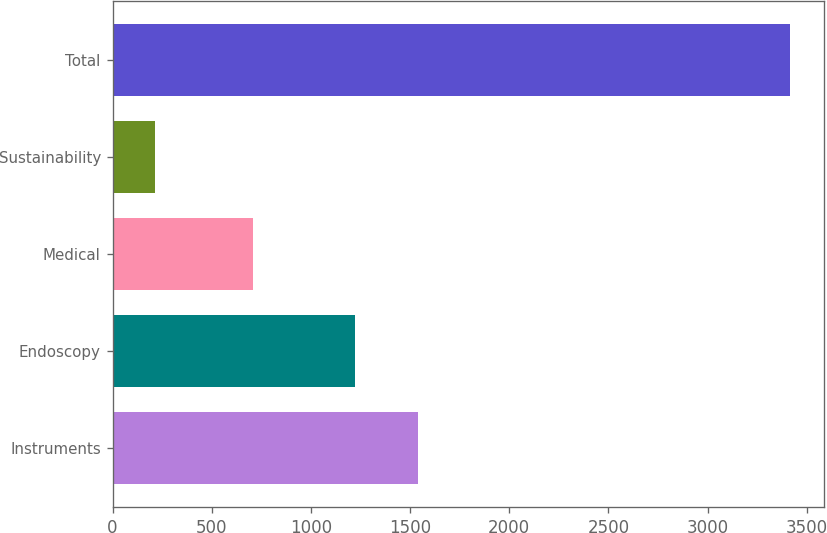Convert chart. <chart><loc_0><loc_0><loc_500><loc_500><bar_chart><fcel>Instruments<fcel>Endoscopy<fcel>Medical<fcel>Sustainability<fcel>Total<nl><fcel>1542.1<fcel>1222<fcel>710<fcel>213<fcel>3414<nl></chart> 